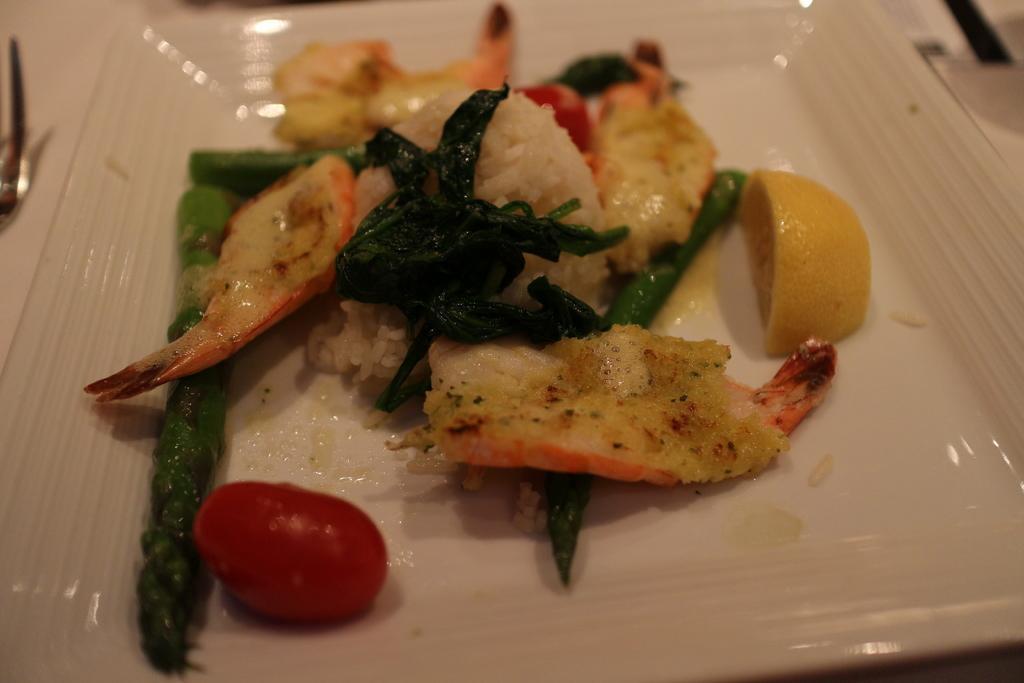In one or two sentences, can you explain what this image depicts? In this picture we can see a plate, there is some food present in this plate. 